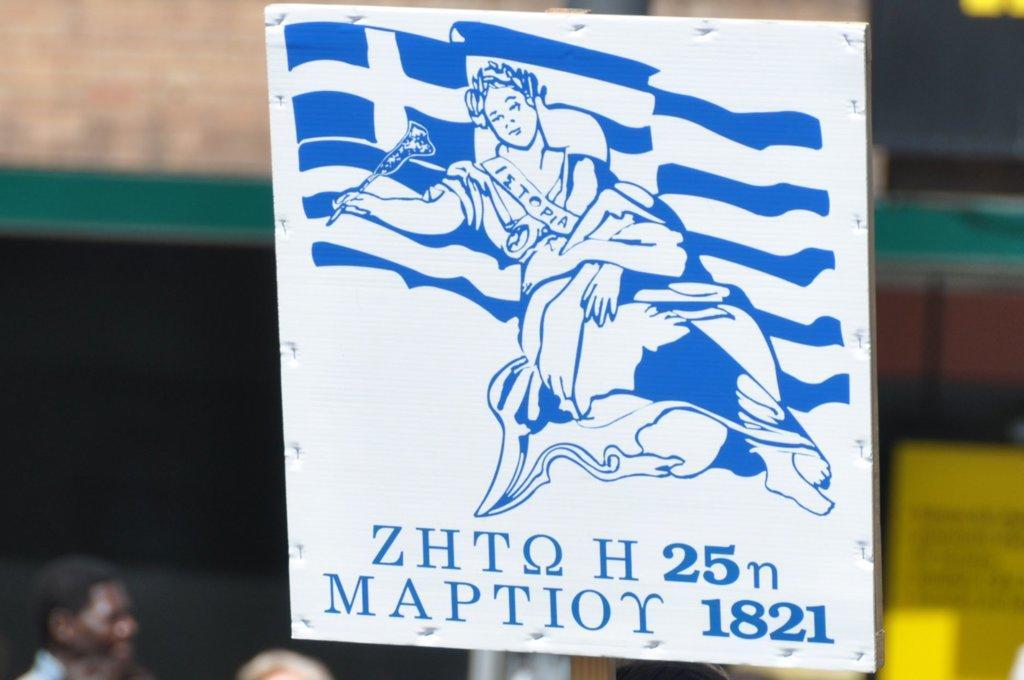Can you describe this image briefly? In the center of the image there is a board. On board we can see painting of person and some text. At the bottom of the image some persons are there. In the background the image is blur. 